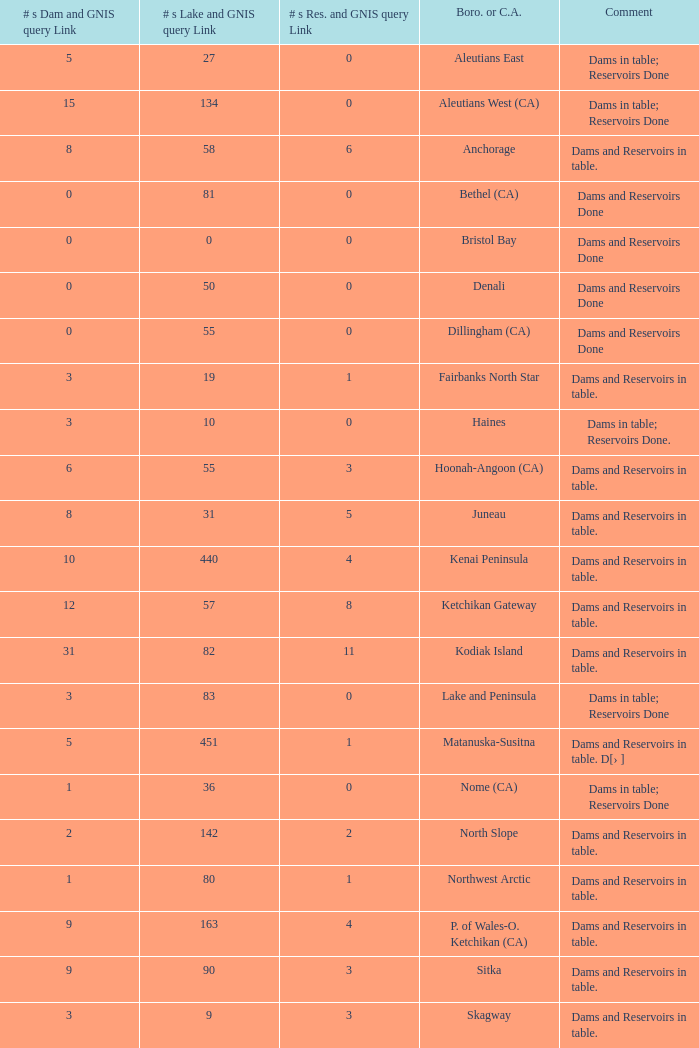Name the minimum number of reservoir for gnis query link where numbers lake gnis query link being 60 5.0. 